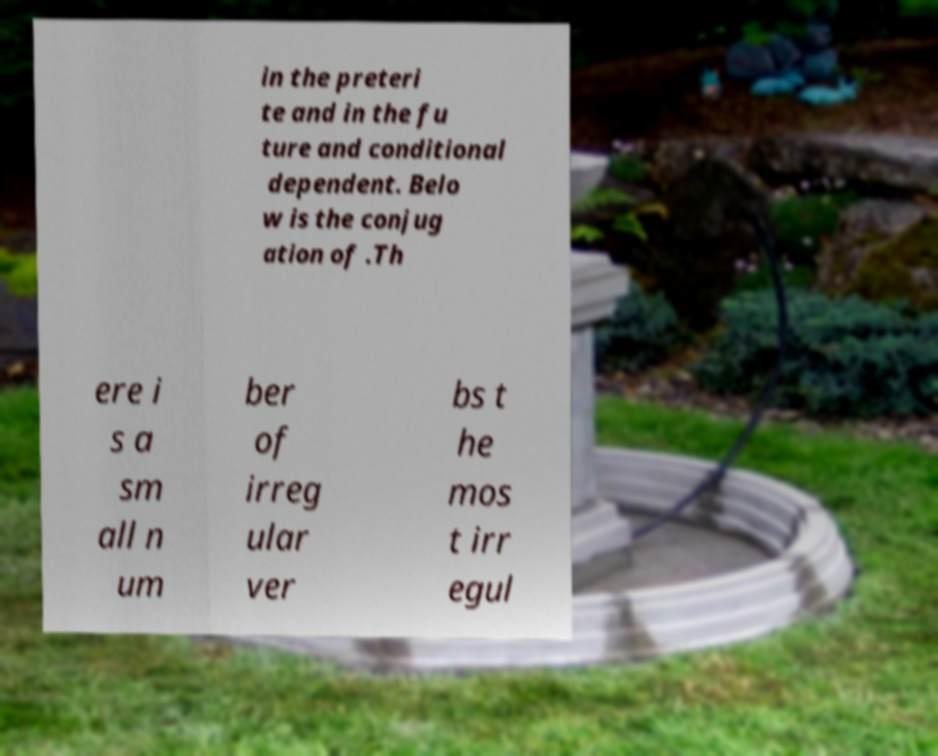Can you read and provide the text displayed in the image?This photo seems to have some interesting text. Can you extract and type it out for me? in the preteri te and in the fu ture and conditional dependent. Belo w is the conjug ation of .Th ere i s a sm all n um ber of irreg ular ver bs t he mos t irr egul 